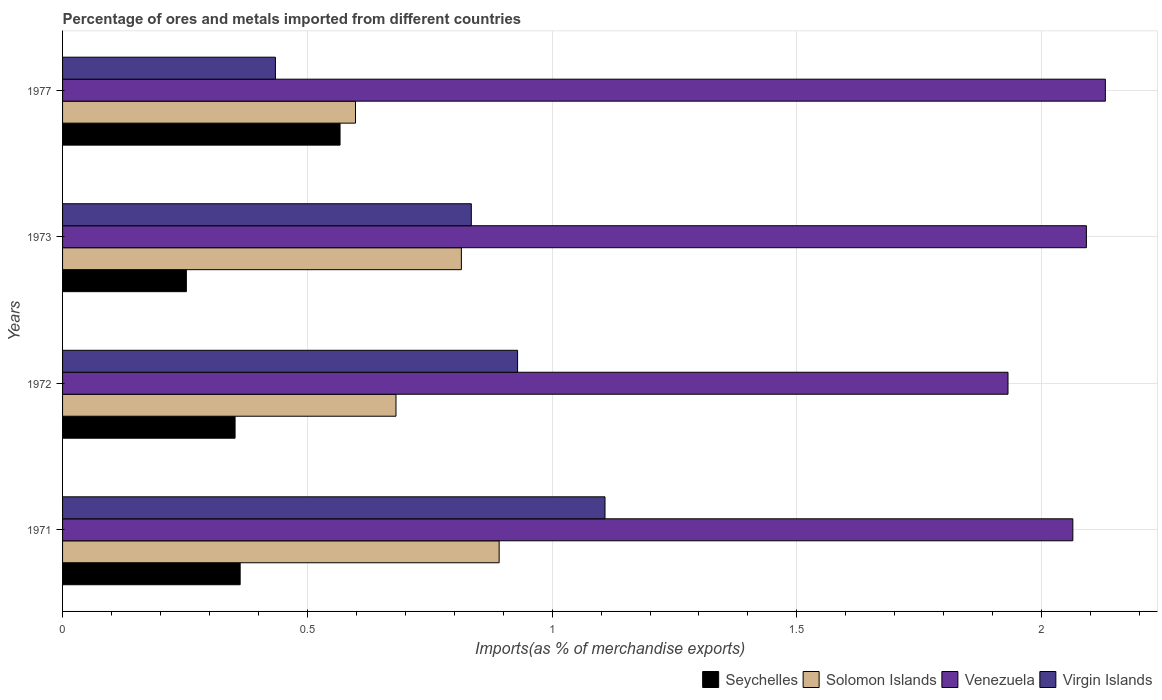How many groups of bars are there?
Offer a terse response. 4. How many bars are there on the 1st tick from the top?
Your answer should be compact. 4. How many bars are there on the 4th tick from the bottom?
Your response must be concise. 4. In how many cases, is the number of bars for a given year not equal to the number of legend labels?
Offer a very short reply. 0. What is the percentage of imports to different countries in Venezuela in 1977?
Ensure brevity in your answer.  2.13. Across all years, what is the maximum percentage of imports to different countries in Seychelles?
Make the answer very short. 0.57. Across all years, what is the minimum percentage of imports to different countries in Solomon Islands?
Your answer should be very brief. 0.6. What is the total percentage of imports to different countries in Solomon Islands in the graph?
Ensure brevity in your answer.  2.99. What is the difference between the percentage of imports to different countries in Solomon Islands in 1971 and that in 1973?
Provide a succinct answer. 0.08. What is the difference between the percentage of imports to different countries in Venezuela in 1971 and the percentage of imports to different countries in Virgin Islands in 1972?
Provide a succinct answer. 1.13. What is the average percentage of imports to different countries in Virgin Islands per year?
Ensure brevity in your answer.  0.83. In the year 1973, what is the difference between the percentage of imports to different countries in Seychelles and percentage of imports to different countries in Virgin Islands?
Your answer should be very brief. -0.58. In how many years, is the percentage of imports to different countries in Virgin Islands greater than 2.1 %?
Ensure brevity in your answer.  0. What is the ratio of the percentage of imports to different countries in Virgin Islands in 1971 to that in 1972?
Provide a succinct answer. 1.19. Is the percentage of imports to different countries in Venezuela in 1971 less than that in 1973?
Offer a very short reply. Yes. What is the difference between the highest and the second highest percentage of imports to different countries in Seychelles?
Your answer should be compact. 0.2. What is the difference between the highest and the lowest percentage of imports to different countries in Seychelles?
Offer a terse response. 0.31. In how many years, is the percentage of imports to different countries in Solomon Islands greater than the average percentage of imports to different countries in Solomon Islands taken over all years?
Make the answer very short. 2. Is it the case that in every year, the sum of the percentage of imports to different countries in Solomon Islands and percentage of imports to different countries in Virgin Islands is greater than the sum of percentage of imports to different countries in Venezuela and percentage of imports to different countries in Seychelles?
Keep it short and to the point. No. What does the 2nd bar from the top in 1977 represents?
Offer a very short reply. Venezuela. What does the 2nd bar from the bottom in 1977 represents?
Provide a succinct answer. Solomon Islands. How many bars are there?
Make the answer very short. 16. How many years are there in the graph?
Ensure brevity in your answer.  4. Are the values on the major ticks of X-axis written in scientific E-notation?
Keep it short and to the point. No. Does the graph contain grids?
Your answer should be very brief. Yes. Where does the legend appear in the graph?
Your response must be concise. Bottom right. What is the title of the graph?
Your response must be concise. Percentage of ores and metals imported from different countries. What is the label or title of the X-axis?
Keep it short and to the point. Imports(as % of merchandise exports). What is the label or title of the Y-axis?
Provide a short and direct response. Years. What is the Imports(as % of merchandise exports) of Seychelles in 1971?
Ensure brevity in your answer.  0.36. What is the Imports(as % of merchandise exports) in Solomon Islands in 1971?
Your answer should be compact. 0.89. What is the Imports(as % of merchandise exports) in Venezuela in 1971?
Your answer should be compact. 2.06. What is the Imports(as % of merchandise exports) of Virgin Islands in 1971?
Provide a succinct answer. 1.11. What is the Imports(as % of merchandise exports) in Seychelles in 1972?
Your answer should be compact. 0.35. What is the Imports(as % of merchandise exports) in Solomon Islands in 1972?
Offer a very short reply. 0.68. What is the Imports(as % of merchandise exports) in Venezuela in 1972?
Provide a short and direct response. 1.93. What is the Imports(as % of merchandise exports) in Virgin Islands in 1972?
Keep it short and to the point. 0.93. What is the Imports(as % of merchandise exports) in Seychelles in 1973?
Ensure brevity in your answer.  0.25. What is the Imports(as % of merchandise exports) of Solomon Islands in 1973?
Offer a terse response. 0.81. What is the Imports(as % of merchandise exports) of Venezuela in 1973?
Give a very brief answer. 2.09. What is the Imports(as % of merchandise exports) in Virgin Islands in 1973?
Offer a very short reply. 0.83. What is the Imports(as % of merchandise exports) of Seychelles in 1977?
Provide a short and direct response. 0.57. What is the Imports(as % of merchandise exports) in Solomon Islands in 1977?
Ensure brevity in your answer.  0.6. What is the Imports(as % of merchandise exports) in Venezuela in 1977?
Provide a short and direct response. 2.13. What is the Imports(as % of merchandise exports) of Virgin Islands in 1977?
Make the answer very short. 0.43. Across all years, what is the maximum Imports(as % of merchandise exports) in Seychelles?
Ensure brevity in your answer.  0.57. Across all years, what is the maximum Imports(as % of merchandise exports) of Solomon Islands?
Ensure brevity in your answer.  0.89. Across all years, what is the maximum Imports(as % of merchandise exports) of Venezuela?
Give a very brief answer. 2.13. Across all years, what is the maximum Imports(as % of merchandise exports) in Virgin Islands?
Ensure brevity in your answer.  1.11. Across all years, what is the minimum Imports(as % of merchandise exports) of Seychelles?
Make the answer very short. 0.25. Across all years, what is the minimum Imports(as % of merchandise exports) in Solomon Islands?
Your answer should be very brief. 0.6. Across all years, what is the minimum Imports(as % of merchandise exports) in Venezuela?
Ensure brevity in your answer.  1.93. Across all years, what is the minimum Imports(as % of merchandise exports) of Virgin Islands?
Offer a very short reply. 0.43. What is the total Imports(as % of merchandise exports) in Seychelles in the graph?
Your answer should be compact. 1.53. What is the total Imports(as % of merchandise exports) in Solomon Islands in the graph?
Give a very brief answer. 2.99. What is the total Imports(as % of merchandise exports) in Venezuela in the graph?
Your answer should be very brief. 8.22. What is the total Imports(as % of merchandise exports) in Virgin Islands in the graph?
Make the answer very short. 3.31. What is the difference between the Imports(as % of merchandise exports) of Seychelles in 1971 and that in 1972?
Offer a terse response. 0.01. What is the difference between the Imports(as % of merchandise exports) of Solomon Islands in 1971 and that in 1972?
Give a very brief answer. 0.21. What is the difference between the Imports(as % of merchandise exports) of Venezuela in 1971 and that in 1972?
Make the answer very short. 0.13. What is the difference between the Imports(as % of merchandise exports) in Virgin Islands in 1971 and that in 1972?
Provide a succinct answer. 0.18. What is the difference between the Imports(as % of merchandise exports) of Seychelles in 1971 and that in 1973?
Ensure brevity in your answer.  0.11. What is the difference between the Imports(as % of merchandise exports) in Solomon Islands in 1971 and that in 1973?
Provide a succinct answer. 0.08. What is the difference between the Imports(as % of merchandise exports) of Venezuela in 1971 and that in 1973?
Provide a short and direct response. -0.03. What is the difference between the Imports(as % of merchandise exports) of Virgin Islands in 1971 and that in 1973?
Keep it short and to the point. 0.27. What is the difference between the Imports(as % of merchandise exports) in Seychelles in 1971 and that in 1977?
Keep it short and to the point. -0.2. What is the difference between the Imports(as % of merchandise exports) of Solomon Islands in 1971 and that in 1977?
Your answer should be very brief. 0.29. What is the difference between the Imports(as % of merchandise exports) in Venezuela in 1971 and that in 1977?
Your answer should be very brief. -0.07. What is the difference between the Imports(as % of merchandise exports) in Virgin Islands in 1971 and that in 1977?
Ensure brevity in your answer.  0.67. What is the difference between the Imports(as % of merchandise exports) of Seychelles in 1972 and that in 1973?
Your answer should be compact. 0.1. What is the difference between the Imports(as % of merchandise exports) of Solomon Islands in 1972 and that in 1973?
Provide a succinct answer. -0.13. What is the difference between the Imports(as % of merchandise exports) in Venezuela in 1972 and that in 1973?
Your answer should be compact. -0.16. What is the difference between the Imports(as % of merchandise exports) in Virgin Islands in 1972 and that in 1973?
Keep it short and to the point. 0.09. What is the difference between the Imports(as % of merchandise exports) in Seychelles in 1972 and that in 1977?
Your answer should be very brief. -0.21. What is the difference between the Imports(as % of merchandise exports) in Solomon Islands in 1972 and that in 1977?
Make the answer very short. 0.08. What is the difference between the Imports(as % of merchandise exports) of Venezuela in 1972 and that in 1977?
Your response must be concise. -0.2. What is the difference between the Imports(as % of merchandise exports) in Virgin Islands in 1972 and that in 1977?
Make the answer very short. 0.49. What is the difference between the Imports(as % of merchandise exports) of Seychelles in 1973 and that in 1977?
Ensure brevity in your answer.  -0.31. What is the difference between the Imports(as % of merchandise exports) of Solomon Islands in 1973 and that in 1977?
Make the answer very short. 0.22. What is the difference between the Imports(as % of merchandise exports) in Venezuela in 1973 and that in 1977?
Your answer should be compact. -0.04. What is the difference between the Imports(as % of merchandise exports) of Virgin Islands in 1973 and that in 1977?
Give a very brief answer. 0.4. What is the difference between the Imports(as % of merchandise exports) in Seychelles in 1971 and the Imports(as % of merchandise exports) in Solomon Islands in 1972?
Your answer should be very brief. -0.32. What is the difference between the Imports(as % of merchandise exports) of Seychelles in 1971 and the Imports(as % of merchandise exports) of Venezuela in 1972?
Offer a terse response. -1.57. What is the difference between the Imports(as % of merchandise exports) of Seychelles in 1971 and the Imports(as % of merchandise exports) of Virgin Islands in 1972?
Keep it short and to the point. -0.57. What is the difference between the Imports(as % of merchandise exports) of Solomon Islands in 1971 and the Imports(as % of merchandise exports) of Venezuela in 1972?
Your answer should be very brief. -1.04. What is the difference between the Imports(as % of merchandise exports) of Solomon Islands in 1971 and the Imports(as % of merchandise exports) of Virgin Islands in 1972?
Your answer should be very brief. -0.04. What is the difference between the Imports(as % of merchandise exports) in Venezuela in 1971 and the Imports(as % of merchandise exports) in Virgin Islands in 1972?
Keep it short and to the point. 1.13. What is the difference between the Imports(as % of merchandise exports) in Seychelles in 1971 and the Imports(as % of merchandise exports) in Solomon Islands in 1973?
Your answer should be very brief. -0.45. What is the difference between the Imports(as % of merchandise exports) of Seychelles in 1971 and the Imports(as % of merchandise exports) of Venezuela in 1973?
Offer a terse response. -1.73. What is the difference between the Imports(as % of merchandise exports) of Seychelles in 1971 and the Imports(as % of merchandise exports) of Virgin Islands in 1973?
Ensure brevity in your answer.  -0.47. What is the difference between the Imports(as % of merchandise exports) in Solomon Islands in 1971 and the Imports(as % of merchandise exports) in Venezuela in 1973?
Provide a succinct answer. -1.2. What is the difference between the Imports(as % of merchandise exports) in Solomon Islands in 1971 and the Imports(as % of merchandise exports) in Virgin Islands in 1973?
Offer a terse response. 0.06. What is the difference between the Imports(as % of merchandise exports) in Venezuela in 1971 and the Imports(as % of merchandise exports) in Virgin Islands in 1973?
Make the answer very short. 1.23. What is the difference between the Imports(as % of merchandise exports) of Seychelles in 1971 and the Imports(as % of merchandise exports) of Solomon Islands in 1977?
Offer a terse response. -0.24. What is the difference between the Imports(as % of merchandise exports) of Seychelles in 1971 and the Imports(as % of merchandise exports) of Venezuela in 1977?
Make the answer very short. -1.77. What is the difference between the Imports(as % of merchandise exports) in Seychelles in 1971 and the Imports(as % of merchandise exports) in Virgin Islands in 1977?
Keep it short and to the point. -0.07. What is the difference between the Imports(as % of merchandise exports) of Solomon Islands in 1971 and the Imports(as % of merchandise exports) of Venezuela in 1977?
Give a very brief answer. -1.24. What is the difference between the Imports(as % of merchandise exports) in Solomon Islands in 1971 and the Imports(as % of merchandise exports) in Virgin Islands in 1977?
Give a very brief answer. 0.46. What is the difference between the Imports(as % of merchandise exports) of Venezuela in 1971 and the Imports(as % of merchandise exports) of Virgin Islands in 1977?
Give a very brief answer. 1.63. What is the difference between the Imports(as % of merchandise exports) in Seychelles in 1972 and the Imports(as % of merchandise exports) in Solomon Islands in 1973?
Make the answer very short. -0.46. What is the difference between the Imports(as % of merchandise exports) in Seychelles in 1972 and the Imports(as % of merchandise exports) in Venezuela in 1973?
Make the answer very short. -1.74. What is the difference between the Imports(as % of merchandise exports) in Seychelles in 1972 and the Imports(as % of merchandise exports) in Virgin Islands in 1973?
Keep it short and to the point. -0.48. What is the difference between the Imports(as % of merchandise exports) of Solomon Islands in 1972 and the Imports(as % of merchandise exports) of Venezuela in 1973?
Ensure brevity in your answer.  -1.41. What is the difference between the Imports(as % of merchandise exports) of Solomon Islands in 1972 and the Imports(as % of merchandise exports) of Virgin Islands in 1973?
Give a very brief answer. -0.15. What is the difference between the Imports(as % of merchandise exports) in Venezuela in 1972 and the Imports(as % of merchandise exports) in Virgin Islands in 1973?
Give a very brief answer. 1.1. What is the difference between the Imports(as % of merchandise exports) in Seychelles in 1972 and the Imports(as % of merchandise exports) in Solomon Islands in 1977?
Your answer should be compact. -0.25. What is the difference between the Imports(as % of merchandise exports) of Seychelles in 1972 and the Imports(as % of merchandise exports) of Venezuela in 1977?
Your answer should be compact. -1.78. What is the difference between the Imports(as % of merchandise exports) of Seychelles in 1972 and the Imports(as % of merchandise exports) of Virgin Islands in 1977?
Offer a terse response. -0.08. What is the difference between the Imports(as % of merchandise exports) in Solomon Islands in 1972 and the Imports(as % of merchandise exports) in Venezuela in 1977?
Offer a very short reply. -1.45. What is the difference between the Imports(as % of merchandise exports) in Solomon Islands in 1972 and the Imports(as % of merchandise exports) in Virgin Islands in 1977?
Provide a short and direct response. 0.25. What is the difference between the Imports(as % of merchandise exports) of Venezuela in 1972 and the Imports(as % of merchandise exports) of Virgin Islands in 1977?
Your answer should be very brief. 1.5. What is the difference between the Imports(as % of merchandise exports) of Seychelles in 1973 and the Imports(as % of merchandise exports) of Solomon Islands in 1977?
Provide a short and direct response. -0.35. What is the difference between the Imports(as % of merchandise exports) of Seychelles in 1973 and the Imports(as % of merchandise exports) of Venezuela in 1977?
Make the answer very short. -1.88. What is the difference between the Imports(as % of merchandise exports) in Seychelles in 1973 and the Imports(as % of merchandise exports) in Virgin Islands in 1977?
Your answer should be very brief. -0.18. What is the difference between the Imports(as % of merchandise exports) of Solomon Islands in 1973 and the Imports(as % of merchandise exports) of Venezuela in 1977?
Keep it short and to the point. -1.32. What is the difference between the Imports(as % of merchandise exports) in Solomon Islands in 1973 and the Imports(as % of merchandise exports) in Virgin Islands in 1977?
Provide a short and direct response. 0.38. What is the difference between the Imports(as % of merchandise exports) in Venezuela in 1973 and the Imports(as % of merchandise exports) in Virgin Islands in 1977?
Ensure brevity in your answer.  1.66. What is the average Imports(as % of merchandise exports) of Seychelles per year?
Provide a succinct answer. 0.38. What is the average Imports(as % of merchandise exports) in Solomon Islands per year?
Give a very brief answer. 0.75. What is the average Imports(as % of merchandise exports) of Venezuela per year?
Provide a short and direct response. 2.05. What is the average Imports(as % of merchandise exports) in Virgin Islands per year?
Offer a terse response. 0.83. In the year 1971, what is the difference between the Imports(as % of merchandise exports) of Seychelles and Imports(as % of merchandise exports) of Solomon Islands?
Make the answer very short. -0.53. In the year 1971, what is the difference between the Imports(as % of merchandise exports) in Seychelles and Imports(as % of merchandise exports) in Venezuela?
Your answer should be very brief. -1.7. In the year 1971, what is the difference between the Imports(as % of merchandise exports) in Seychelles and Imports(as % of merchandise exports) in Virgin Islands?
Offer a very short reply. -0.75. In the year 1971, what is the difference between the Imports(as % of merchandise exports) of Solomon Islands and Imports(as % of merchandise exports) of Venezuela?
Offer a terse response. -1.17. In the year 1971, what is the difference between the Imports(as % of merchandise exports) of Solomon Islands and Imports(as % of merchandise exports) of Virgin Islands?
Keep it short and to the point. -0.22. In the year 1971, what is the difference between the Imports(as % of merchandise exports) in Venezuela and Imports(as % of merchandise exports) in Virgin Islands?
Your answer should be very brief. 0.96. In the year 1972, what is the difference between the Imports(as % of merchandise exports) of Seychelles and Imports(as % of merchandise exports) of Solomon Islands?
Provide a short and direct response. -0.33. In the year 1972, what is the difference between the Imports(as % of merchandise exports) of Seychelles and Imports(as % of merchandise exports) of Venezuela?
Your response must be concise. -1.58. In the year 1972, what is the difference between the Imports(as % of merchandise exports) in Seychelles and Imports(as % of merchandise exports) in Virgin Islands?
Your answer should be compact. -0.58. In the year 1972, what is the difference between the Imports(as % of merchandise exports) in Solomon Islands and Imports(as % of merchandise exports) in Venezuela?
Keep it short and to the point. -1.25. In the year 1972, what is the difference between the Imports(as % of merchandise exports) in Solomon Islands and Imports(as % of merchandise exports) in Virgin Islands?
Your answer should be compact. -0.25. In the year 1973, what is the difference between the Imports(as % of merchandise exports) in Seychelles and Imports(as % of merchandise exports) in Solomon Islands?
Your response must be concise. -0.56. In the year 1973, what is the difference between the Imports(as % of merchandise exports) of Seychelles and Imports(as % of merchandise exports) of Venezuela?
Ensure brevity in your answer.  -1.84. In the year 1973, what is the difference between the Imports(as % of merchandise exports) in Seychelles and Imports(as % of merchandise exports) in Virgin Islands?
Your answer should be compact. -0.58. In the year 1973, what is the difference between the Imports(as % of merchandise exports) in Solomon Islands and Imports(as % of merchandise exports) in Venezuela?
Your answer should be very brief. -1.28. In the year 1973, what is the difference between the Imports(as % of merchandise exports) in Solomon Islands and Imports(as % of merchandise exports) in Virgin Islands?
Your response must be concise. -0.02. In the year 1973, what is the difference between the Imports(as % of merchandise exports) of Venezuela and Imports(as % of merchandise exports) of Virgin Islands?
Provide a short and direct response. 1.26. In the year 1977, what is the difference between the Imports(as % of merchandise exports) of Seychelles and Imports(as % of merchandise exports) of Solomon Islands?
Your answer should be very brief. -0.03. In the year 1977, what is the difference between the Imports(as % of merchandise exports) in Seychelles and Imports(as % of merchandise exports) in Venezuela?
Ensure brevity in your answer.  -1.56. In the year 1977, what is the difference between the Imports(as % of merchandise exports) in Seychelles and Imports(as % of merchandise exports) in Virgin Islands?
Offer a terse response. 0.13. In the year 1977, what is the difference between the Imports(as % of merchandise exports) in Solomon Islands and Imports(as % of merchandise exports) in Venezuela?
Your answer should be compact. -1.53. In the year 1977, what is the difference between the Imports(as % of merchandise exports) in Solomon Islands and Imports(as % of merchandise exports) in Virgin Islands?
Provide a short and direct response. 0.16. In the year 1977, what is the difference between the Imports(as % of merchandise exports) of Venezuela and Imports(as % of merchandise exports) of Virgin Islands?
Keep it short and to the point. 1.7. What is the ratio of the Imports(as % of merchandise exports) in Seychelles in 1971 to that in 1972?
Your response must be concise. 1.03. What is the ratio of the Imports(as % of merchandise exports) in Solomon Islands in 1971 to that in 1972?
Ensure brevity in your answer.  1.31. What is the ratio of the Imports(as % of merchandise exports) of Venezuela in 1971 to that in 1972?
Offer a very short reply. 1.07. What is the ratio of the Imports(as % of merchandise exports) in Virgin Islands in 1971 to that in 1972?
Offer a very short reply. 1.19. What is the ratio of the Imports(as % of merchandise exports) in Seychelles in 1971 to that in 1973?
Your response must be concise. 1.43. What is the ratio of the Imports(as % of merchandise exports) in Solomon Islands in 1971 to that in 1973?
Your answer should be compact. 1.09. What is the ratio of the Imports(as % of merchandise exports) in Venezuela in 1971 to that in 1973?
Your answer should be compact. 0.99. What is the ratio of the Imports(as % of merchandise exports) of Virgin Islands in 1971 to that in 1973?
Offer a terse response. 1.33. What is the ratio of the Imports(as % of merchandise exports) in Seychelles in 1971 to that in 1977?
Give a very brief answer. 0.64. What is the ratio of the Imports(as % of merchandise exports) of Solomon Islands in 1971 to that in 1977?
Ensure brevity in your answer.  1.49. What is the ratio of the Imports(as % of merchandise exports) of Venezuela in 1971 to that in 1977?
Give a very brief answer. 0.97. What is the ratio of the Imports(as % of merchandise exports) in Virgin Islands in 1971 to that in 1977?
Make the answer very short. 2.55. What is the ratio of the Imports(as % of merchandise exports) in Seychelles in 1972 to that in 1973?
Your response must be concise. 1.39. What is the ratio of the Imports(as % of merchandise exports) of Solomon Islands in 1972 to that in 1973?
Your answer should be compact. 0.84. What is the ratio of the Imports(as % of merchandise exports) of Venezuela in 1972 to that in 1973?
Keep it short and to the point. 0.92. What is the ratio of the Imports(as % of merchandise exports) of Virgin Islands in 1972 to that in 1973?
Provide a short and direct response. 1.11. What is the ratio of the Imports(as % of merchandise exports) of Seychelles in 1972 to that in 1977?
Make the answer very short. 0.62. What is the ratio of the Imports(as % of merchandise exports) in Solomon Islands in 1972 to that in 1977?
Keep it short and to the point. 1.14. What is the ratio of the Imports(as % of merchandise exports) of Venezuela in 1972 to that in 1977?
Your answer should be very brief. 0.91. What is the ratio of the Imports(as % of merchandise exports) of Virgin Islands in 1972 to that in 1977?
Ensure brevity in your answer.  2.14. What is the ratio of the Imports(as % of merchandise exports) of Seychelles in 1973 to that in 1977?
Keep it short and to the point. 0.45. What is the ratio of the Imports(as % of merchandise exports) in Solomon Islands in 1973 to that in 1977?
Make the answer very short. 1.36. What is the ratio of the Imports(as % of merchandise exports) of Venezuela in 1973 to that in 1977?
Give a very brief answer. 0.98. What is the ratio of the Imports(as % of merchandise exports) of Virgin Islands in 1973 to that in 1977?
Your response must be concise. 1.92. What is the difference between the highest and the second highest Imports(as % of merchandise exports) in Seychelles?
Your answer should be very brief. 0.2. What is the difference between the highest and the second highest Imports(as % of merchandise exports) in Solomon Islands?
Make the answer very short. 0.08. What is the difference between the highest and the second highest Imports(as % of merchandise exports) in Venezuela?
Offer a very short reply. 0.04. What is the difference between the highest and the second highest Imports(as % of merchandise exports) of Virgin Islands?
Provide a short and direct response. 0.18. What is the difference between the highest and the lowest Imports(as % of merchandise exports) in Seychelles?
Your answer should be compact. 0.31. What is the difference between the highest and the lowest Imports(as % of merchandise exports) in Solomon Islands?
Offer a very short reply. 0.29. What is the difference between the highest and the lowest Imports(as % of merchandise exports) in Venezuela?
Your response must be concise. 0.2. What is the difference between the highest and the lowest Imports(as % of merchandise exports) in Virgin Islands?
Keep it short and to the point. 0.67. 